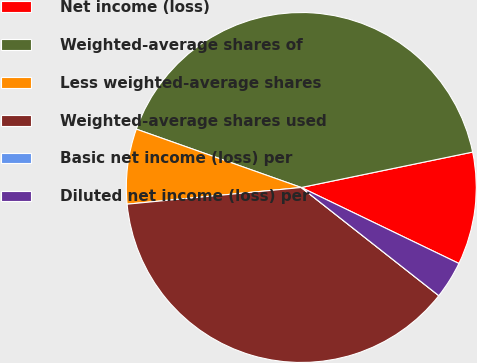Convert chart to OTSL. <chart><loc_0><loc_0><loc_500><loc_500><pie_chart><fcel>Net income (loss)<fcel>Weighted-average shares of<fcel>Less weighted-average shares<fcel>Weighted-average shares used<fcel>Basic net income (loss) per<fcel>Diluted net income (loss) per<nl><fcel>10.39%<fcel>41.34%<fcel>6.93%<fcel>37.87%<fcel>0.0%<fcel>3.46%<nl></chart> 